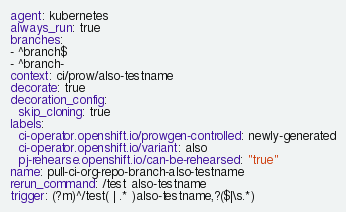Convert code to text. <code><loc_0><loc_0><loc_500><loc_500><_YAML_>agent: kubernetes
always_run: true
branches:
- ^branch$
- ^branch-
context: ci/prow/also-testname
decorate: true
decoration_config:
  skip_cloning: true
labels:
  ci-operator.openshift.io/prowgen-controlled: newly-generated
  ci-operator.openshift.io/variant: also
  pj-rehearse.openshift.io/can-be-rehearsed: "true"
name: pull-ci-org-repo-branch-also-testname
rerun_command: /test also-testname
trigger: (?m)^/test( | .* )also-testname,?($|\s.*)
</code> 